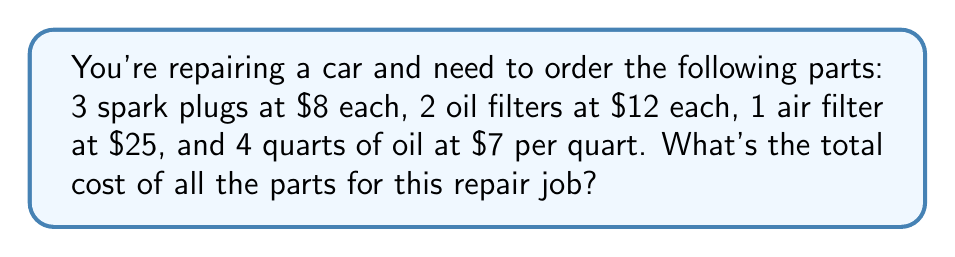Show me your answer to this math problem. Let's break down the cost calculation step by step:

1. Spark plugs:
   $3 \times $8 = $24$

2. Oil filters:
   $2 \times $12 = $24$

3. Air filter:
   $1 \times $25 = $25$

4. Oil:
   $4 \times $7 = $28$

Now, let's add up all these costs:

$$\text{Total cost} = $24 + $24 + $25 + $28 = $101$$

Therefore, the total cost of all the parts for this repair job is $101.
Answer: $101 